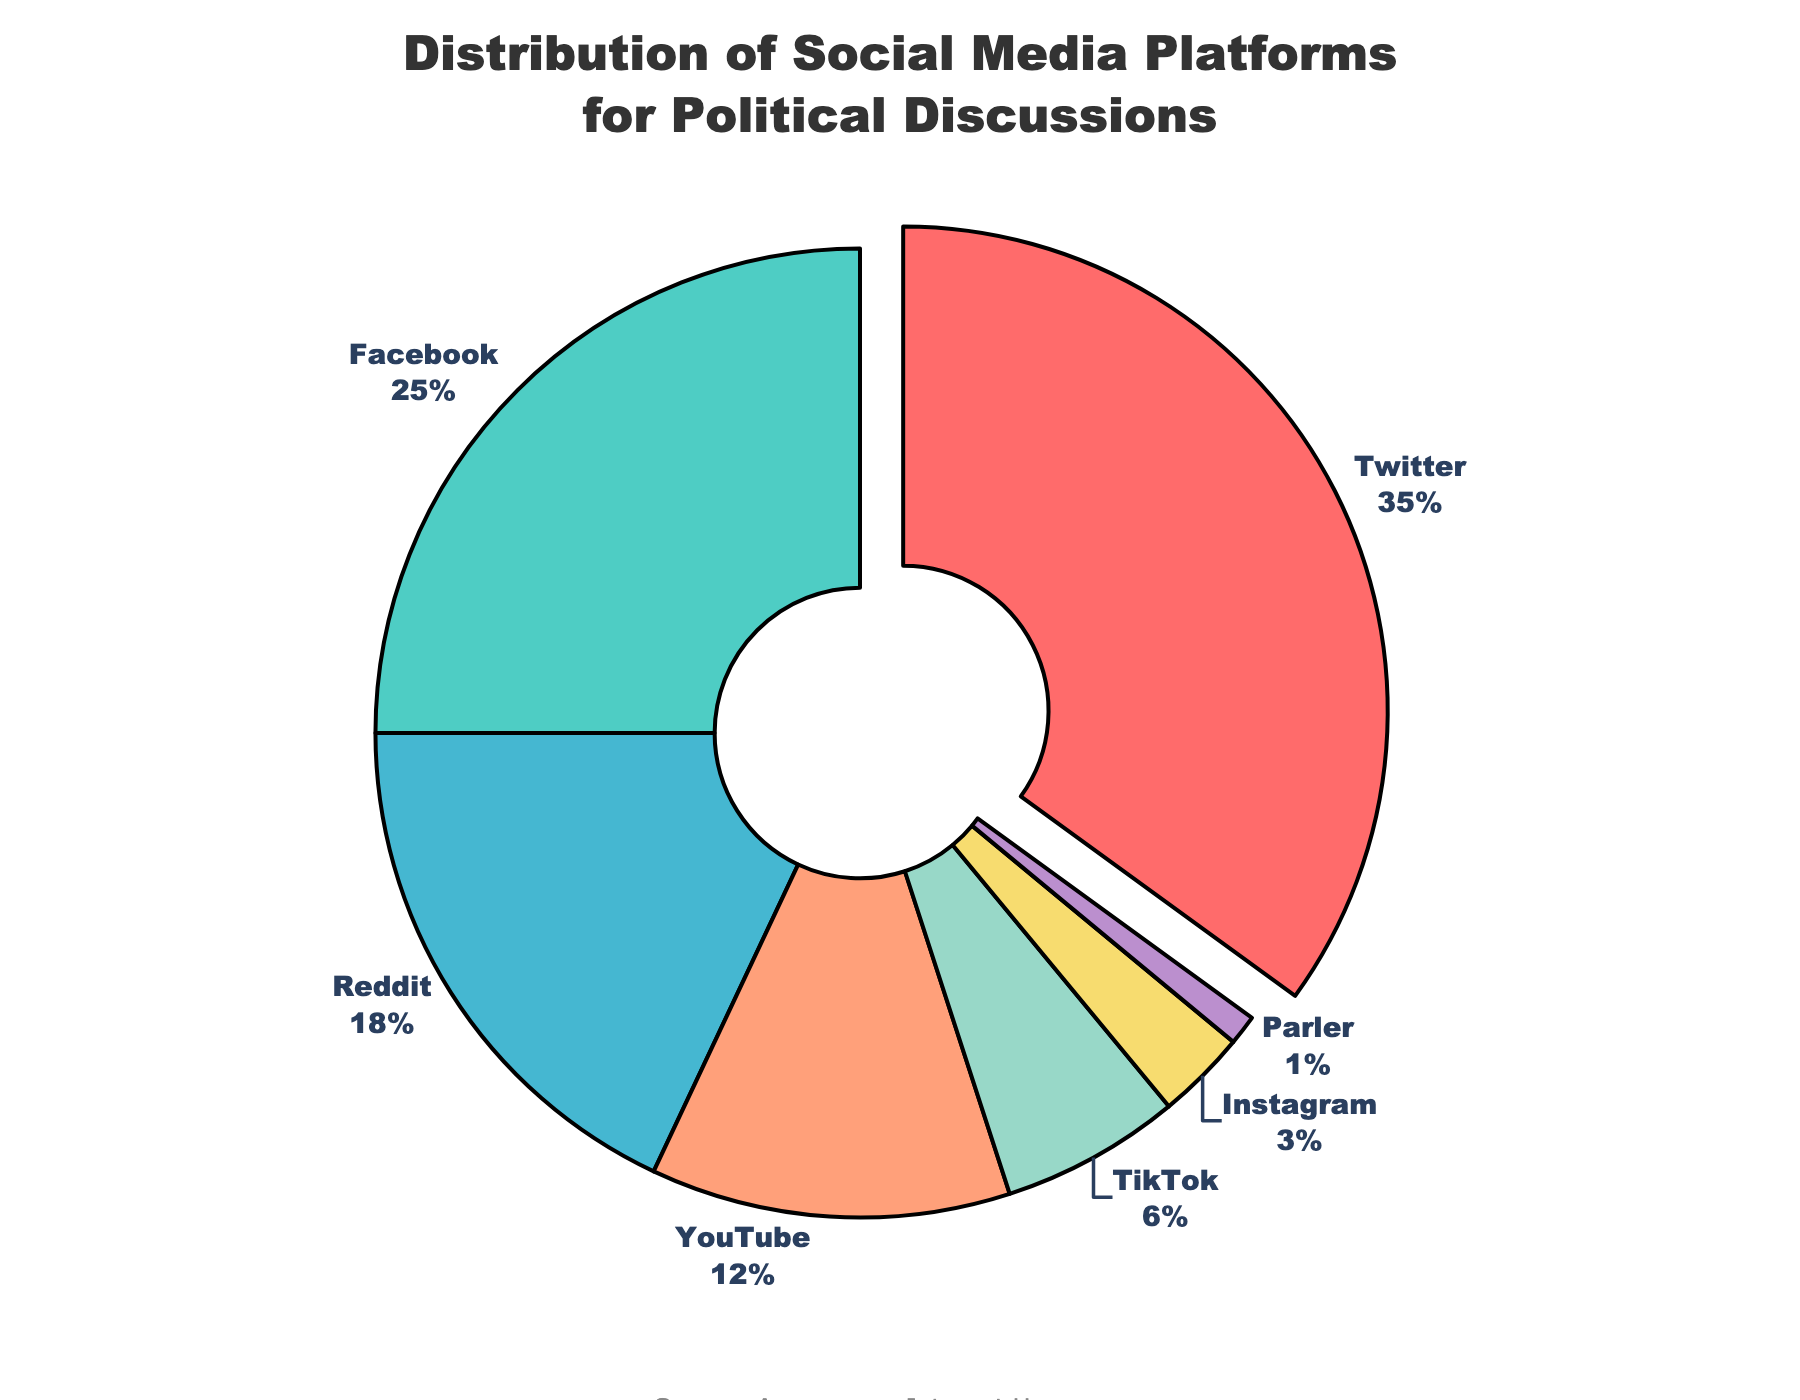How much more percentage does Twitter have compared to Instagram? Twitter has a percentage of 35% while Instagram has 3%. The difference is 35% - 3% = 32%.
Answer: 32% Which platform has the second highest percentage of users? Twitter has the highest with 35%, and Facebook comes next with 25%.
Answer: Facebook How many total percentages are covered by Twitter and TikTok together? Twitter has 35% and TikTok has 6%. Together, they sum up to 35% + 6% = 41%.
Answer: 41% Which platform has the smallest segment and what’s its percentage? The smallest segment is Parler, with 1%.
Answer: Parler, 1% List the platforms that have a percentage equal to or greater than 10%. The platforms with equal to or more than 10% are Twitter (35%), Facebook (25%), Reddit (18%), and YouTube (12%).
Answer: Twitter, Facebook, Reddit, YouTube How does Facebook's percentage compare to the combined percentages of TikTok and Instagram? Facebook has 25%. TikTok and Instagram combined have 6% + 3% = 9%. Facebook's percentage is greater than their combined percentage by 25% - 9% = 16%.
Answer: Facebook’s percentage is greater by 16% Which color represents the Reddit segment? Refer to the color assignment in the plot, Reddit is represented by a distinct color (#45B7D1). Without specific hex codes, it's identified by the unique shade among the segments.
Answer: Blue (in chart context) What is the sum of percentages of platforms under 10%? TikTok has 6%, Instagram has 3%, and Parler has 1%. Their sum is 6% + 3% + 1% = 10%.
Answer: 10% Out of YouTube and Reddit, which has a higher percentage and by how much? Reddit has 18% and YouTube has 12%. Reddit’s percentage is higher by 18% - 12% = 6%.
Answer: Reddit, 6% Calculate the average percentage of all the platforms shown in the chart. Sum the percentages: 35% (Twitter) + 25% (Facebook) + 18% (Reddit) + 12% (YouTube) + 6% (TikTok) + 3% (Instagram) + 1% (Parler) = 100%. There are 7 platforms, so the average is 100% / 7 ≈ 14.29%.
Answer: 14.29% 